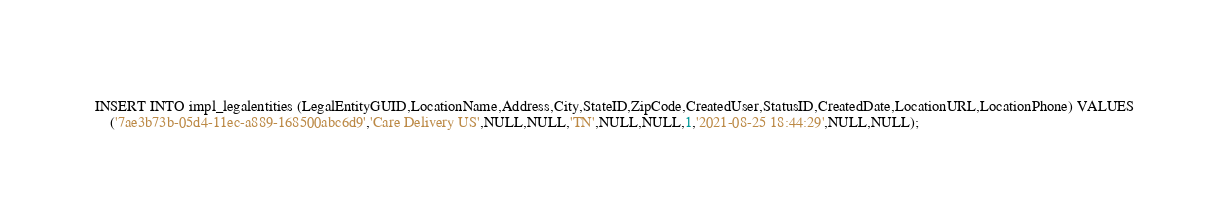<code> <loc_0><loc_0><loc_500><loc_500><_SQL_>INSERT INTO impl_legalentities (LegalEntityGUID,LocationName,Address,City,StateID,ZipCode,CreatedUser,StatusID,CreatedDate,LocationURL,LocationPhone) VALUES
    ('7ae3b73b-05d4-11ec-a889-168500abc6d9','Care Delivery US',NULL,NULL,'TN',NULL,NULL,1,'2021-08-25 18:44:29',NULL,NULL);</code> 